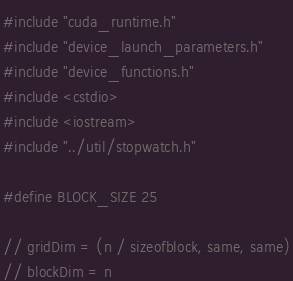<code> <loc_0><loc_0><loc_500><loc_500><_Cuda_>#include "cuda_runtime.h"
#include "device_launch_parameters.h"
#include "device_functions.h"
#include <cstdio>
#include <iostream>
#include "../util/stopwatch.h"

#define BLOCK_SIZE 25

// gridDim = (n / sizeofblock, same, same)
// blockDim = n</code> 